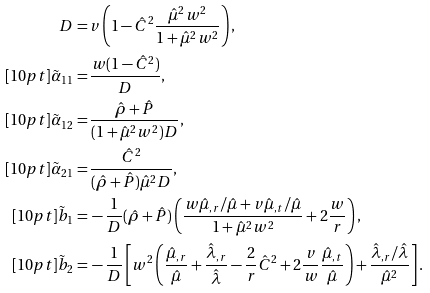Convert formula to latex. <formula><loc_0><loc_0><loc_500><loc_500>D = & \, v \left ( 1 - \hat { C } ^ { 2 } \frac { \hat { \mu } ^ { 2 } w ^ { 2 } } { 1 + \hat { \mu } ^ { 2 } w ^ { 2 } } \right ) , \\ [ 1 0 p t ] \tilde { \alpha } _ { 1 1 } = & \, \frac { w ( 1 - \hat { C } ^ { 2 } ) } { D } , \\ [ 1 0 p t ] \tilde { \alpha } _ { 1 2 } = & \, \frac { \hat { \rho } + \hat { P } } { ( 1 + \hat { \mu } ^ { 2 } w ^ { 2 } ) D } , \\ [ 1 0 p t ] \tilde { \alpha } _ { 2 1 } = & \, \frac { \hat { C } ^ { 2 } } { ( \hat { \rho } + \hat { P } ) \hat { \mu } ^ { 2 } D } , \\ [ 1 0 p t ] \tilde { b } _ { 1 } = & \, - \frac { 1 } { D } ( \hat { \rho } + \hat { P } ) \left ( \frac { w \hat { \mu } _ { , r } / \hat { \mu } + v \hat { \mu } _ { , t } / \hat { \mu } } { 1 + \hat { \mu } ^ { 2 } w ^ { 2 } } + 2 \frac { w } { r } \right ) , \\ [ 1 0 p t ] \tilde { b } _ { 2 } = & \, - \frac { 1 } { D } \left [ w ^ { 2 } \left ( \frac { \hat { \mu } _ { , r } } { \hat { \mu } } + \frac { \hat { \lambda } _ { , r } } { \hat { \lambda } } - \frac { 2 } { r } \hat { C } ^ { 2 } + 2 \frac { v } { w } \frac { \hat { \mu } _ { , t } } { \hat { \mu } } \right ) + \frac { \hat { \lambda } _ { , r } / \hat { \lambda } } { \hat { \mu } ^ { 2 } } \right ] .</formula> 